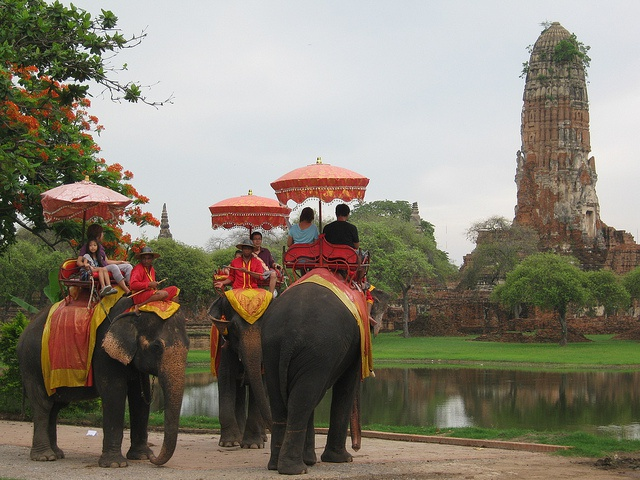Describe the objects in this image and their specific colors. I can see elephant in black, maroon, olive, and brown tones, elephant in black, maroon, and brown tones, elephant in black, maroon, and olive tones, umbrella in black, brown, and lightpink tones, and people in black, brown, and maroon tones in this image. 